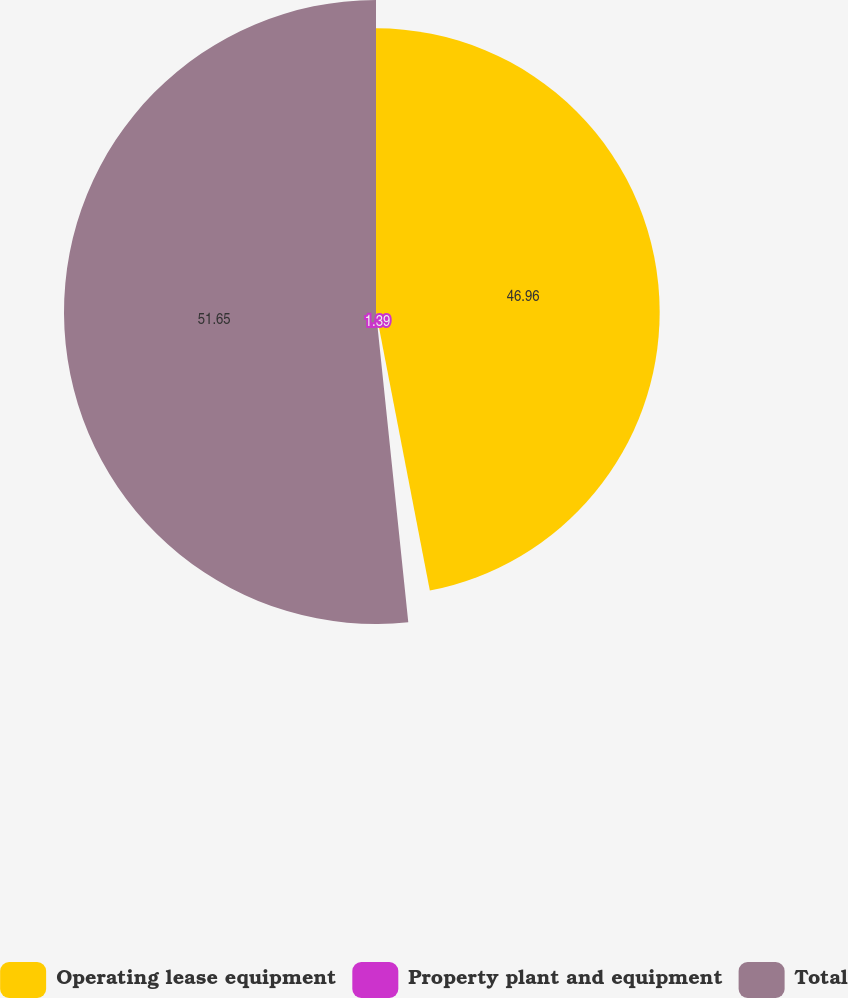Convert chart to OTSL. <chart><loc_0><loc_0><loc_500><loc_500><pie_chart><fcel>Operating lease equipment<fcel>Property plant and equipment<fcel>Total<nl><fcel>46.96%<fcel>1.39%<fcel>51.65%<nl></chart> 